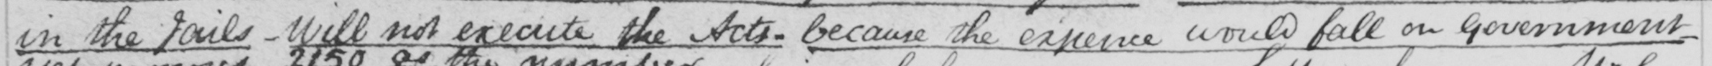What text is written in this handwritten line? in the Jails  _  Will not execute the Acts  _  because the expence would fall on government 